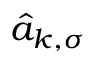Convert formula to latex. <formula><loc_0><loc_0><loc_500><loc_500>\hat { a } _ { k , \sigma }</formula> 